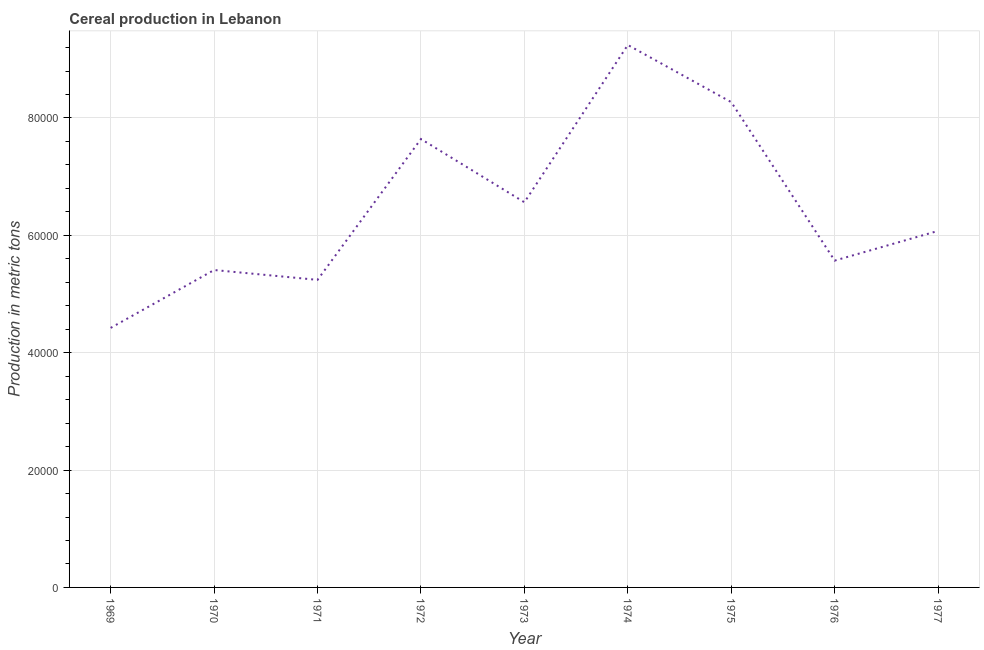What is the cereal production in 1970?
Give a very brief answer. 5.41e+04. Across all years, what is the maximum cereal production?
Offer a very short reply. 9.24e+04. Across all years, what is the minimum cereal production?
Provide a succinct answer. 4.42e+04. In which year was the cereal production maximum?
Provide a short and direct response. 1974. In which year was the cereal production minimum?
Your answer should be very brief. 1969. What is the sum of the cereal production?
Provide a short and direct response. 5.84e+05. What is the difference between the cereal production in 1969 and 1973?
Make the answer very short. -2.14e+04. What is the average cereal production per year?
Your answer should be compact. 6.49e+04. What is the median cereal production?
Offer a very short reply. 6.08e+04. In how many years, is the cereal production greater than 76000 metric tons?
Keep it short and to the point. 3. Do a majority of the years between 1971 and 1972 (inclusive) have cereal production greater than 4000 metric tons?
Provide a short and direct response. Yes. What is the ratio of the cereal production in 1969 to that in 1977?
Make the answer very short. 0.73. Is the cereal production in 1972 less than that in 1976?
Your answer should be very brief. No. Is the difference between the cereal production in 1975 and 1976 greater than the difference between any two years?
Offer a terse response. No. What is the difference between the highest and the second highest cereal production?
Your response must be concise. 9744. What is the difference between the highest and the lowest cereal production?
Give a very brief answer. 4.82e+04. Does the cereal production monotonically increase over the years?
Your answer should be compact. No. How many lines are there?
Offer a terse response. 1. How many years are there in the graph?
Keep it short and to the point. 9. What is the title of the graph?
Offer a very short reply. Cereal production in Lebanon. What is the label or title of the X-axis?
Give a very brief answer. Year. What is the label or title of the Y-axis?
Your answer should be very brief. Production in metric tons. What is the Production in metric tons of 1969?
Keep it short and to the point. 4.42e+04. What is the Production in metric tons of 1970?
Make the answer very short. 5.41e+04. What is the Production in metric tons of 1971?
Make the answer very short. 5.24e+04. What is the Production in metric tons of 1972?
Your answer should be very brief. 7.64e+04. What is the Production in metric tons in 1973?
Ensure brevity in your answer.  6.56e+04. What is the Production in metric tons of 1974?
Your answer should be compact. 9.24e+04. What is the Production in metric tons in 1975?
Provide a short and direct response. 8.27e+04. What is the Production in metric tons of 1976?
Your response must be concise. 5.57e+04. What is the Production in metric tons in 1977?
Offer a very short reply. 6.08e+04. What is the difference between the Production in metric tons in 1969 and 1970?
Ensure brevity in your answer.  -9864. What is the difference between the Production in metric tons in 1969 and 1971?
Provide a short and direct response. -8186. What is the difference between the Production in metric tons in 1969 and 1972?
Make the answer very short. -3.22e+04. What is the difference between the Production in metric tons in 1969 and 1973?
Keep it short and to the point. -2.14e+04. What is the difference between the Production in metric tons in 1969 and 1974?
Keep it short and to the point. -4.82e+04. What is the difference between the Production in metric tons in 1969 and 1975?
Keep it short and to the point. -3.85e+04. What is the difference between the Production in metric tons in 1969 and 1976?
Provide a succinct answer. -1.15e+04. What is the difference between the Production in metric tons in 1969 and 1977?
Your answer should be compact. -1.65e+04. What is the difference between the Production in metric tons in 1970 and 1971?
Keep it short and to the point. 1678. What is the difference between the Production in metric tons in 1970 and 1972?
Your answer should be compact. -2.23e+04. What is the difference between the Production in metric tons in 1970 and 1973?
Provide a succinct answer. -1.15e+04. What is the difference between the Production in metric tons in 1970 and 1974?
Your response must be concise. -3.84e+04. What is the difference between the Production in metric tons in 1970 and 1975?
Make the answer very short. -2.86e+04. What is the difference between the Production in metric tons in 1970 and 1976?
Your response must be concise. -1608. What is the difference between the Production in metric tons in 1970 and 1977?
Your answer should be compact. -6668. What is the difference between the Production in metric tons in 1971 and 1972?
Offer a very short reply. -2.40e+04. What is the difference between the Production in metric tons in 1971 and 1973?
Make the answer very short. -1.32e+04. What is the difference between the Production in metric tons in 1971 and 1974?
Make the answer very short. -4.00e+04. What is the difference between the Production in metric tons in 1971 and 1975?
Offer a terse response. -3.03e+04. What is the difference between the Production in metric tons in 1971 and 1976?
Your response must be concise. -3286. What is the difference between the Production in metric tons in 1971 and 1977?
Ensure brevity in your answer.  -8346. What is the difference between the Production in metric tons in 1972 and 1973?
Offer a very short reply. 1.08e+04. What is the difference between the Production in metric tons in 1972 and 1974?
Provide a succinct answer. -1.60e+04. What is the difference between the Production in metric tons in 1972 and 1975?
Offer a very short reply. -6284. What is the difference between the Production in metric tons in 1972 and 1976?
Your response must be concise. 2.07e+04. What is the difference between the Production in metric tons in 1972 and 1977?
Make the answer very short. 1.57e+04. What is the difference between the Production in metric tons in 1973 and 1974?
Give a very brief answer. -2.68e+04. What is the difference between the Production in metric tons in 1973 and 1975?
Make the answer very short. -1.71e+04. What is the difference between the Production in metric tons in 1973 and 1976?
Offer a terse response. 9938. What is the difference between the Production in metric tons in 1973 and 1977?
Give a very brief answer. 4878. What is the difference between the Production in metric tons in 1974 and 1975?
Ensure brevity in your answer.  9744. What is the difference between the Production in metric tons in 1974 and 1976?
Your answer should be compact. 3.67e+04. What is the difference between the Production in metric tons in 1974 and 1977?
Ensure brevity in your answer.  3.17e+04. What is the difference between the Production in metric tons in 1975 and 1976?
Give a very brief answer. 2.70e+04. What is the difference between the Production in metric tons in 1975 and 1977?
Your answer should be very brief. 2.19e+04. What is the difference between the Production in metric tons in 1976 and 1977?
Make the answer very short. -5060. What is the ratio of the Production in metric tons in 1969 to that in 1970?
Ensure brevity in your answer.  0.82. What is the ratio of the Production in metric tons in 1969 to that in 1971?
Ensure brevity in your answer.  0.84. What is the ratio of the Production in metric tons in 1969 to that in 1972?
Your answer should be compact. 0.58. What is the ratio of the Production in metric tons in 1969 to that in 1973?
Provide a succinct answer. 0.67. What is the ratio of the Production in metric tons in 1969 to that in 1974?
Make the answer very short. 0.48. What is the ratio of the Production in metric tons in 1969 to that in 1975?
Keep it short and to the point. 0.54. What is the ratio of the Production in metric tons in 1969 to that in 1976?
Your response must be concise. 0.79. What is the ratio of the Production in metric tons in 1969 to that in 1977?
Provide a short and direct response. 0.73. What is the ratio of the Production in metric tons in 1970 to that in 1971?
Your response must be concise. 1.03. What is the ratio of the Production in metric tons in 1970 to that in 1972?
Your answer should be very brief. 0.71. What is the ratio of the Production in metric tons in 1970 to that in 1973?
Give a very brief answer. 0.82. What is the ratio of the Production in metric tons in 1970 to that in 1974?
Offer a terse response. 0.58. What is the ratio of the Production in metric tons in 1970 to that in 1975?
Your response must be concise. 0.65. What is the ratio of the Production in metric tons in 1970 to that in 1976?
Offer a terse response. 0.97. What is the ratio of the Production in metric tons in 1970 to that in 1977?
Provide a succinct answer. 0.89. What is the ratio of the Production in metric tons in 1971 to that in 1972?
Your answer should be compact. 0.69. What is the ratio of the Production in metric tons in 1971 to that in 1973?
Your response must be concise. 0.8. What is the ratio of the Production in metric tons in 1971 to that in 1974?
Provide a short and direct response. 0.57. What is the ratio of the Production in metric tons in 1971 to that in 1975?
Offer a terse response. 0.63. What is the ratio of the Production in metric tons in 1971 to that in 1976?
Give a very brief answer. 0.94. What is the ratio of the Production in metric tons in 1971 to that in 1977?
Make the answer very short. 0.86. What is the ratio of the Production in metric tons in 1972 to that in 1973?
Offer a very short reply. 1.16. What is the ratio of the Production in metric tons in 1972 to that in 1974?
Offer a terse response. 0.83. What is the ratio of the Production in metric tons in 1972 to that in 1975?
Provide a short and direct response. 0.92. What is the ratio of the Production in metric tons in 1972 to that in 1976?
Your answer should be compact. 1.37. What is the ratio of the Production in metric tons in 1972 to that in 1977?
Ensure brevity in your answer.  1.26. What is the ratio of the Production in metric tons in 1973 to that in 1974?
Offer a very short reply. 0.71. What is the ratio of the Production in metric tons in 1973 to that in 1975?
Offer a very short reply. 0.79. What is the ratio of the Production in metric tons in 1973 to that in 1976?
Provide a succinct answer. 1.18. What is the ratio of the Production in metric tons in 1974 to that in 1975?
Make the answer very short. 1.12. What is the ratio of the Production in metric tons in 1974 to that in 1976?
Keep it short and to the point. 1.66. What is the ratio of the Production in metric tons in 1974 to that in 1977?
Offer a terse response. 1.52. What is the ratio of the Production in metric tons in 1975 to that in 1976?
Offer a terse response. 1.49. What is the ratio of the Production in metric tons in 1975 to that in 1977?
Keep it short and to the point. 1.36. What is the ratio of the Production in metric tons in 1976 to that in 1977?
Provide a short and direct response. 0.92. 